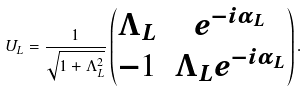Convert formula to latex. <formula><loc_0><loc_0><loc_500><loc_500>U _ { L } = \frac { 1 } { \sqrt { 1 + \Lambda _ { L } ^ { 2 } } } \begin{pmatrix} \Lambda _ { L } & e ^ { - i \alpha _ { L } } \\ - 1 & \Lambda _ { L } e ^ { - i \alpha _ { L } } \end{pmatrix} .</formula> 